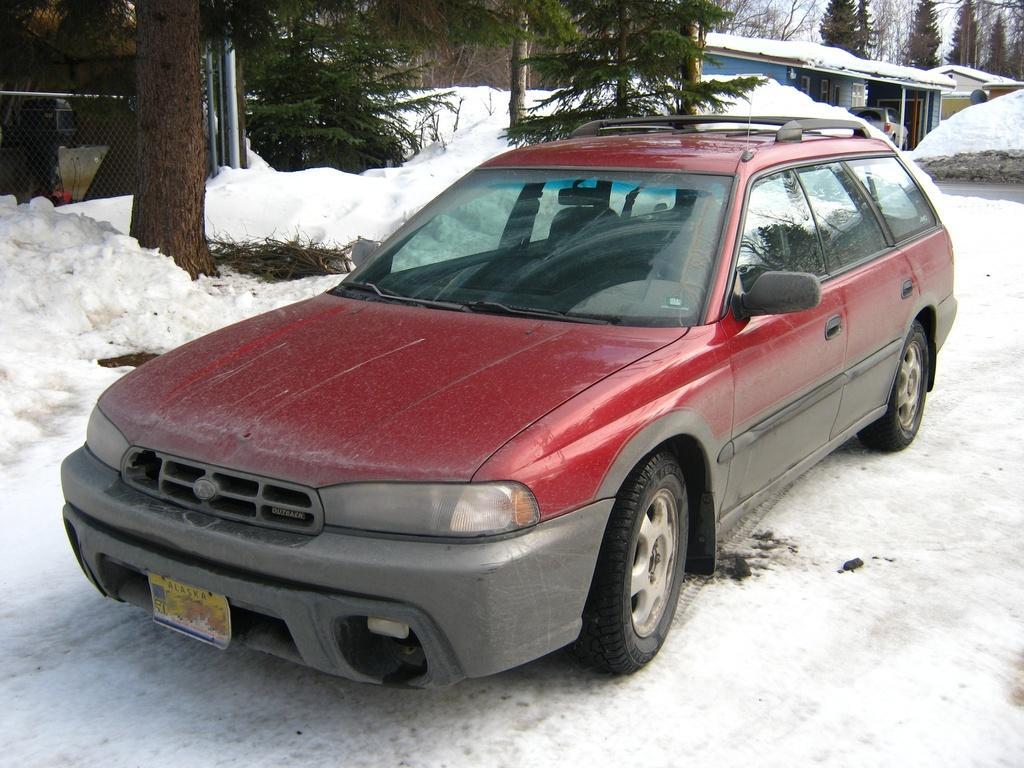In one or two sentences, can you explain what this image depicts? In the foreground of the picture we can see a car and snow. Towards left there are trees, snow and fencing. Towards right there are trees, building, car, snow, road and sky. 